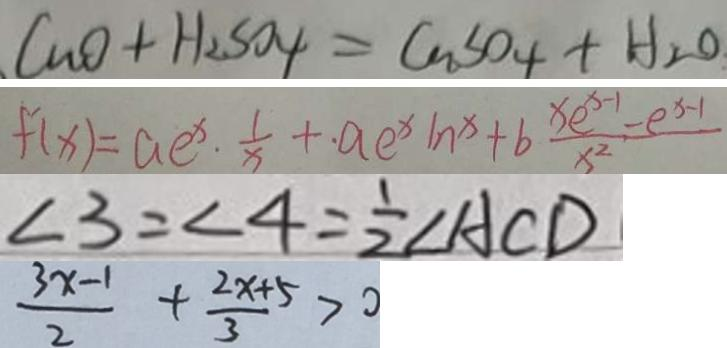Convert formula to latex. <formula><loc_0><loc_0><loc_500><loc_500>C u O + H _ { 2 } S O _ { 4 } = C u S O _ { 4 } + H _ { 2 } O 
 f ^ { \prime } ( x ) = a e ^ { x } \cdot \frac { 1 } { x } + a e ^ { x } \ln x + b \frac { x e ^ { x - 1 } - e ^ { x - 1 } } { x ^ { 2 } } 
 \angle 3 = \angle 4 = \frac { 1 } { 2 } \angle A C D 
 \frac { 3 x - 1 } { 2 } + \frac { 2 x + 5 } { 3 } > 0</formula> 